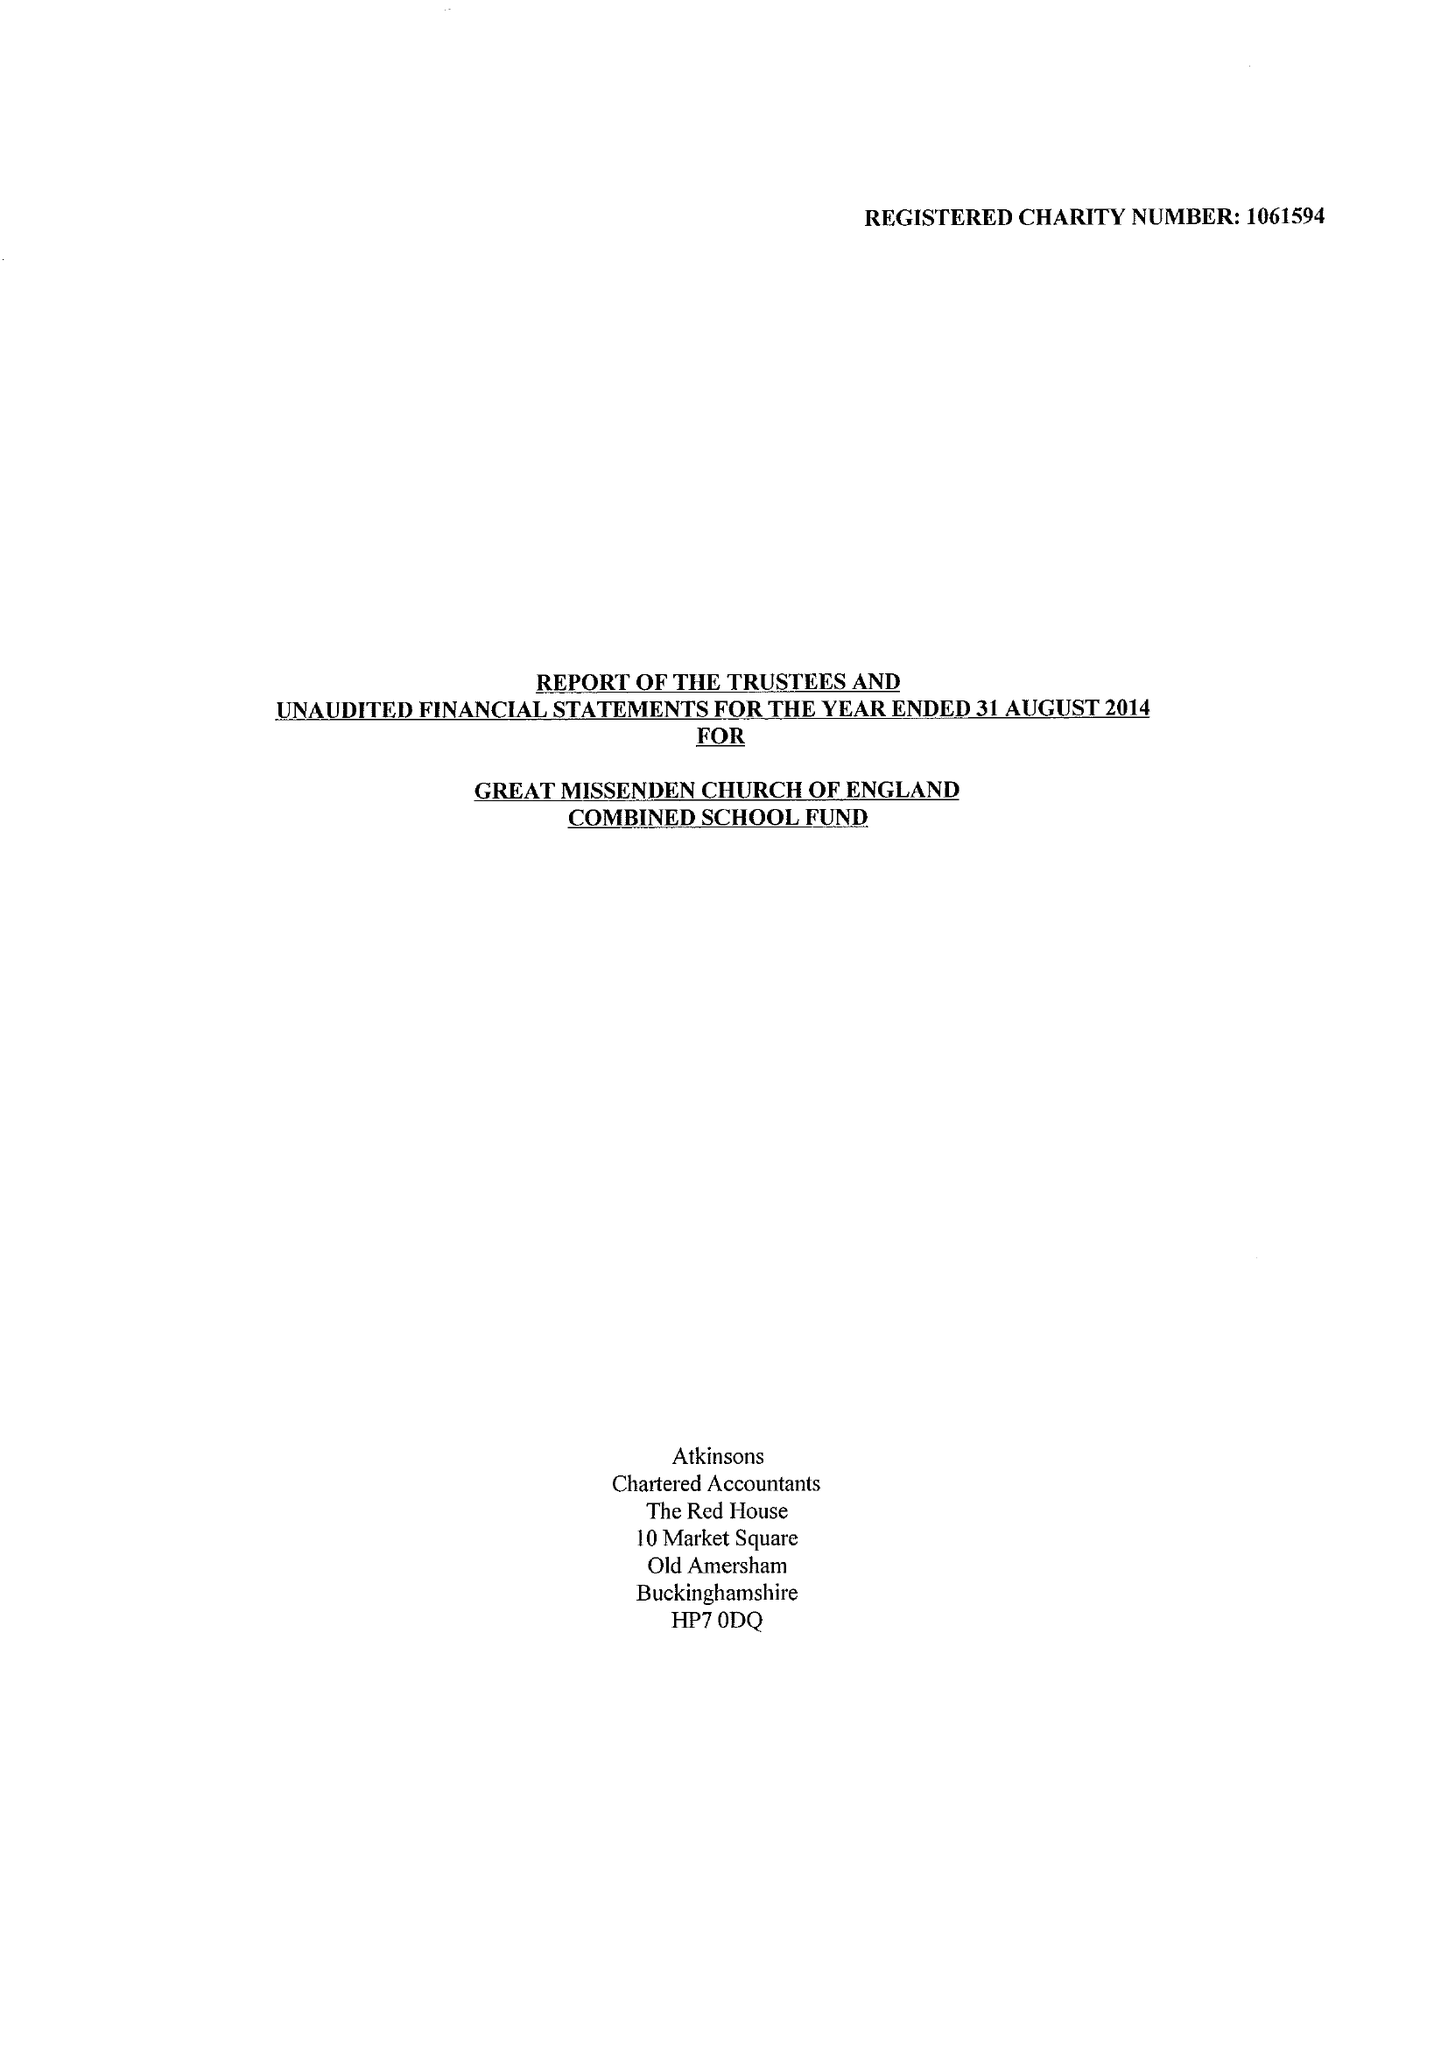What is the value for the spending_annually_in_british_pounds?
Answer the question using a single word or phrase. 359333.00 